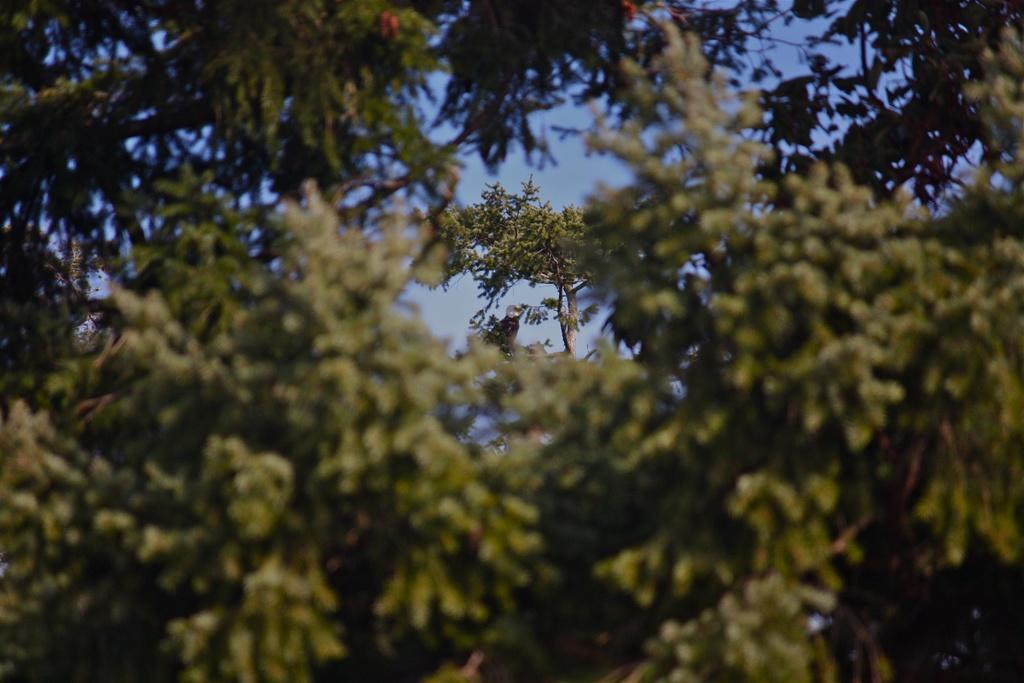What type of vegetation can be seen in the image? There are branches of trees in the image. What part of the natural environment is visible in the image? The sky is visible in the image. How many scarves can be seen hanging from the branches in the image? There are no scarves present in the image; it features branches of trees and the sky. 